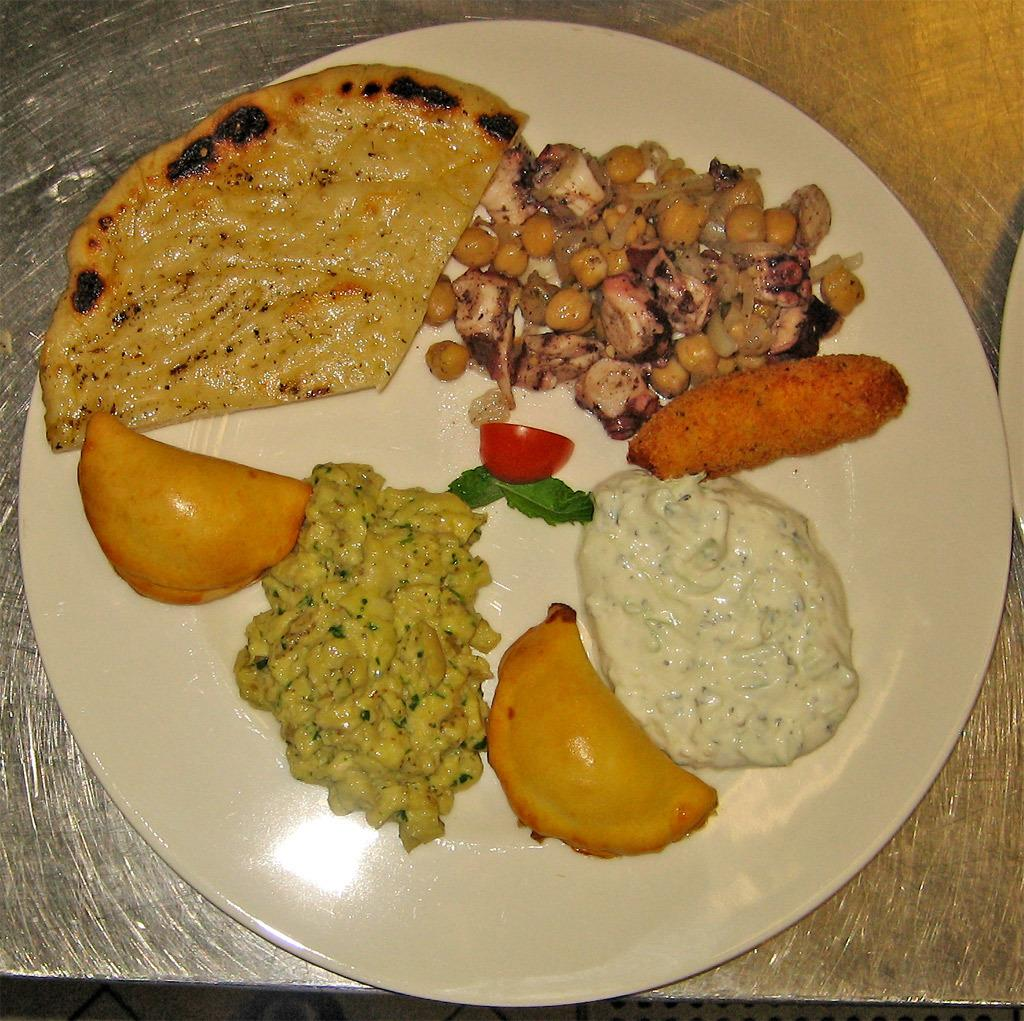What can be seen on the plate in the image? There are food items on a plate in the image. What is the plate placed on? The plate is placed on an object, but the specific object is not mentioned in the facts. How does the fog affect the visibility of the food items on the plate in the image? There is no fog present in the image, so its effect on the visibility of the food items cannot be determined. 